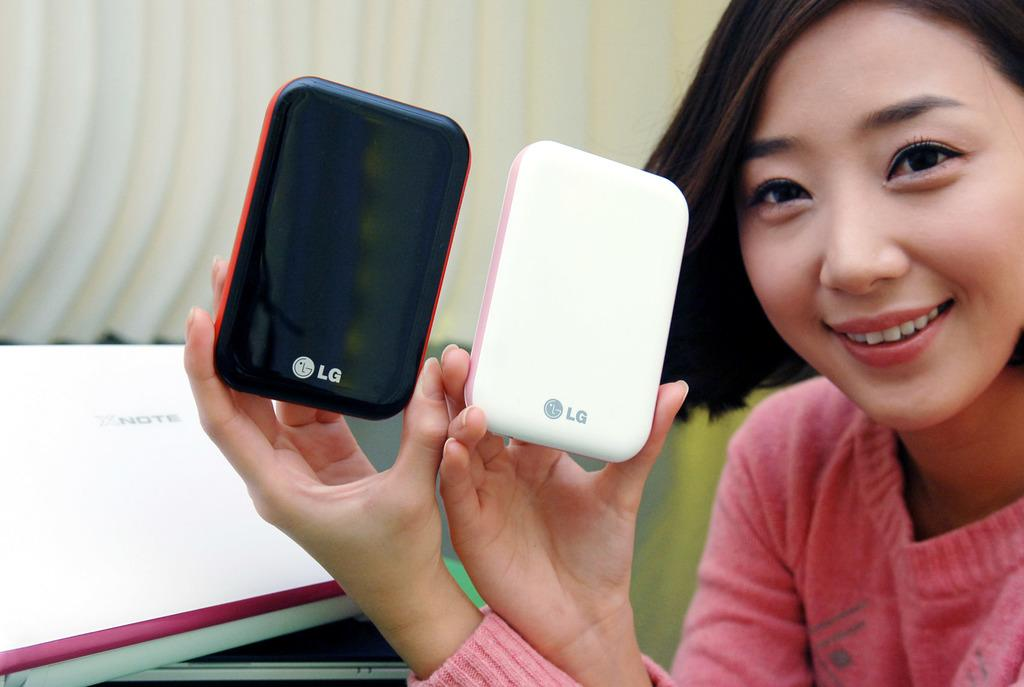Who is the main subject in the image? There is a woman in the image. What is the woman holding in her hand? The woman is holding two mobiles in her hand. How many pigs can be seen in the image? There are no pigs present in the image. What type of boot is the woman wearing in the image? The image does not show the woman's footwear, so it cannot be determined if she is wearing a boot or any other type of footwear. 